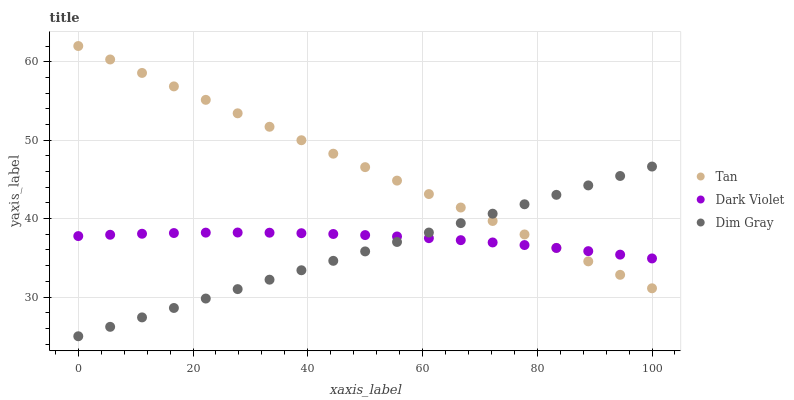Does Dim Gray have the minimum area under the curve?
Answer yes or no. Yes. Does Tan have the maximum area under the curve?
Answer yes or no. Yes. Does Dark Violet have the minimum area under the curve?
Answer yes or no. No. Does Dark Violet have the maximum area under the curve?
Answer yes or no. No. Is Tan the smoothest?
Answer yes or no. Yes. Is Dark Violet the roughest?
Answer yes or no. Yes. Is Dim Gray the smoothest?
Answer yes or no. No. Is Dim Gray the roughest?
Answer yes or no. No. Does Dim Gray have the lowest value?
Answer yes or no. Yes. Does Dark Violet have the lowest value?
Answer yes or no. No. Does Tan have the highest value?
Answer yes or no. Yes. Does Dim Gray have the highest value?
Answer yes or no. No. Does Dim Gray intersect Tan?
Answer yes or no. Yes. Is Dim Gray less than Tan?
Answer yes or no. No. Is Dim Gray greater than Tan?
Answer yes or no. No. 